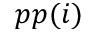<formula> <loc_0><loc_0><loc_500><loc_500>p p ( i )</formula> 